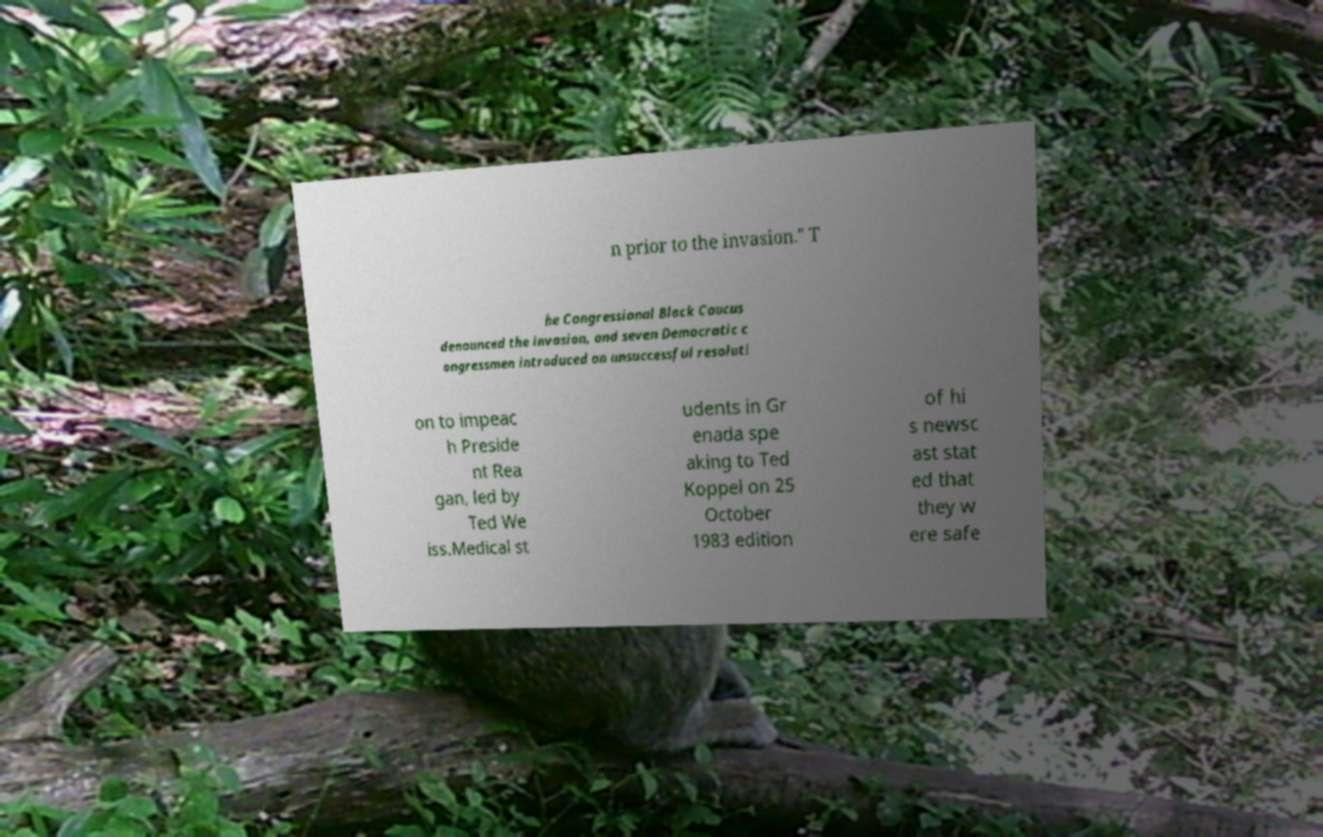I need the written content from this picture converted into text. Can you do that? n prior to the invasion." T he Congressional Black Caucus denounced the invasion, and seven Democratic c ongressmen introduced an unsuccessful resoluti on to impeac h Preside nt Rea gan, led by Ted We iss.Medical st udents in Gr enada spe aking to Ted Koppel on 25 October 1983 edition of hi s newsc ast stat ed that they w ere safe 